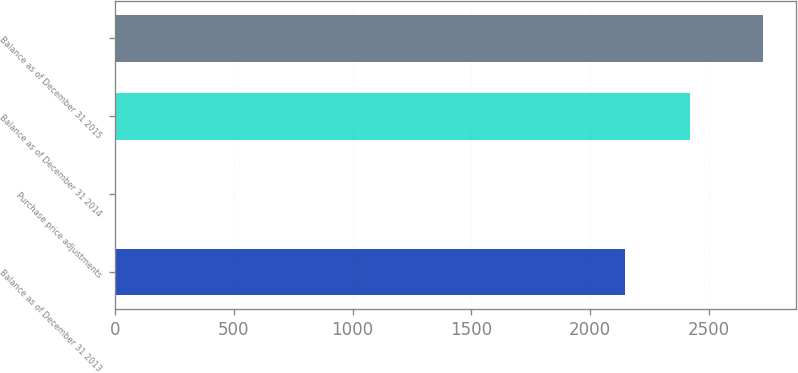Convert chart to OTSL. <chart><loc_0><loc_0><loc_500><loc_500><bar_chart><fcel>Balance as of December 31 2013<fcel>Purchase price adjustments<fcel>Balance as of December 31 2014<fcel>Balance as of December 31 2015<nl><fcel>2147<fcel>2<fcel>2419.8<fcel>2730<nl></chart> 